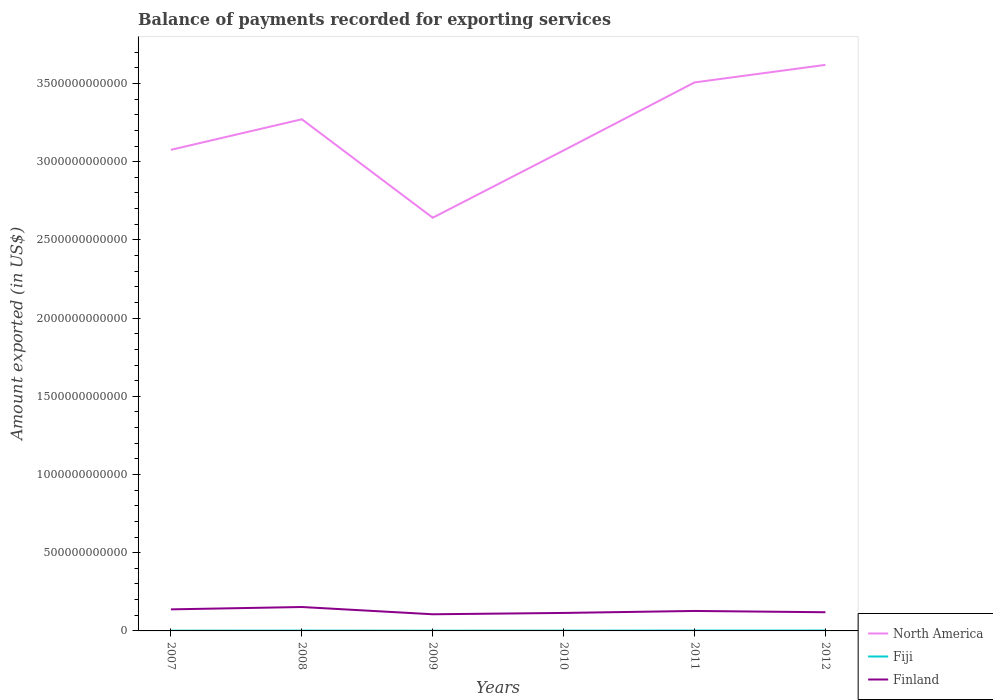How many different coloured lines are there?
Give a very brief answer. 3. Does the line corresponding to North America intersect with the line corresponding to Finland?
Make the answer very short. No. Across all years, what is the maximum amount exported in Finland?
Provide a succinct answer. 1.07e+11. What is the total amount exported in Fiji in the graph?
Provide a short and direct response. -6.14e+08. What is the difference between the highest and the second highest amount exported in Finland?
Your answer should be very brief. 4.63e+1. What is the difference between the highest and the lowest amount exported in Finland?
Your answer should be very brief. 3. How many years are there in the graph?
Provide a short and direct response. 6. What is the difference between two consecutive major ticks on the Y-axis?
Offer a very short reply. 5.00e+11. Does the graph contain any zero values?
Keep it short and to the point. No. Does the graph contain grids?
Give a very brief answer. No. How many legend labels are there?
Your answer should be very brief. 3. How are the legend labels stacked?
Offer a terse response. Vertical. What is the title of the graph?
Your answer should be compact. Balance of payments recorded for exporting services. What is the label or title of the Y-axis?
Provide a succinct answer. Amount exported (in US$). What is the Amount exported (in US$) of North America in 2007?
Your response must be concise. 3.08e+12. What is the Amount exported (in US$) in Fiji in 2007?
Your answer should be very brief. 1.72e+09. What is the Amount exported (in US$) in Finland in 2007?
Your answer should be very brief. 1.38e+11. What is the Amount exported (in US$) of North America in 2008?
Your response must be concise. 3.27e+12. What is the Amount exported (in US$) of Fiji in 2008?
Provide a succinct answer. 2.09e+09. What is the Amount exported (in US$) in Finland in 2008?
Give a very brief answer. 1.53e+11. What is the Amount exported (in US$) of North America in 2009?
Your answer should be very brief. 2.64e+12. What is the Amount exported (in US$) in Fiji in 2009?
Your answer should be very brief. 1.48e+09. What is the Amount exported (in US$) of Finland in 2009?
Offer a terse response. 1.07e+11. What is the Amount exported (in US$) of North America in 2010?
Keep it short and to the point. 3.07e+12. What is the Amount exported (in US$) of Fiji in 2010?
Provide a succinct answer. 1.90e+09. What is the Amount exported (in US$) of Finland in 2010?
Ensure brevity in your answer.  1.15e+11. What is the Amount exported (in US$) of North America in 2011?
Your response must be concise. 3.51e+12. What is the Amount exported (in US$) in Fiji in 2011?
Offer a very short reply. 2.33e+09. What is the Amount exported (in US$) in Finland in 2011?
Provide a succinct answer. 1.28e+11. What is the Amount exported (in US$) in North America in 2012?
Your answer should be very brief. 3.62e+12. What is the Amount exported (in US$) in Fiji in 2012?
Offer a very short reply. 2.51e+09. What is the Amount exported (in US$) of Finland in 2012?
Your response must be concise. 1.20e+11. Across all years, what is the maximum Amount exported (in US$) in North America?
Your response must be concise. 3.62e+12. Across all years, what is the maximum Amount exported (in US$) in Fiji?
Offer a very short reply. 2.51e+09. Across all years, what is the maximum Amount exported (in US$) of Finland?
Your answer should be very brief. 1.53e+11. Across all years, what is the minimum Amount exported (in US$) of North America?
Your answer should be compact. 2.64e+12. Across all years, what is the minimum Amount exported (in US$) of Fiji?
Keep it short and to the point. 1.48e+09. Across all years, what is the minimum Amount exported (in US$) of Finland?
Provide a short and direct response. 1.07e+11. What is the total Amount exported (in US$) of North America in the graph?
Keep it short and to the point. 1.92e+13. What is the total Amount exported (in US$) of Fiji in the graph?
Your answer should be very brief. 1.20e+1. What is the total Amount exported (in US$) of Finland in the graph?
Your answer should be very brief. 7.59e+11. What is the difference between the Amount exported (in US$) in North America in 2007 and that in 2008?
Give a very brief answer. -1.95e+11. What is the difference between the Amount exported (in US$) in Fiji in 2007 and that in 2008?
Make the answer very short. -3.73e+08. What is the difference between the Amount exported (in US$) in Finland in 2007 and that in 2008?
Provide a short and direct response. -1.49e+1. What is the difference between the Amount exported (in US$) of North America in 2007 and that in 2009?
Provide a succinct answer. 4.34e+11. What is the difference between the Amount exported (in US$) of Fiji in 2007 and that in 2009?
Offer a very short reply. 2.34e+08. What is the difference between the Amount exported (in US$) in Finland in 2007 and that in 2009?
Keep it short and to the point. 3.14e+1. What is the difference between the Amount exported (in US$) of North America in 2007 and that in 2010?
Keep it short and to the point. 3.78e+09. What is the difference between the Amount exported (in US$) of Fiji in 2007 and that in 2010?
Keep it short and to the point. -1.82e+08. What is the difference between the Amount exported (in US$) in Finland in 2007 and that in 2010?
Ensure brevity in your answer.  2.29e+1. What is the difference between the Amount exported (in US$) in North America in 2007 and that in 2011?
Keep it short and to the point. -4.31e+11. What is the difference between the Amount exported (in US$) of Fiji in 2007 and that in 2011?
Offer a very short reply. -6.14e+08. What is the difference between the Amount exported (in US$) in Finland in 2007 and that in 2011?
Provide a short and direct response. 1.03e+1. What is the difference between the Amount exported (in US$) in North America in 2007 and that in 2012?
Offer a very short reply. -5.43e+11. What is the difference between the Amount exported (in US$) of Fiji in 2007 and that in 2012?
Keep it short and to the point. -7.94e+08. What is the difference between the Amount exported (in US$) of Finland in 2007 and that in 2012?
Your answer should be compact. 1.84e+1. What is the difference between the Amount exported (in US$) of North America in 2008 and that in 2009?
Give a very brief answer. 6.29e+11. What is the difference between the Amount exported (in US$) of Fiji in 2008 and that in 2009?
Your answer should be very brief. 6.07e+08. What is the difference between the Amount exported (in US$) in Finland in 2008 and that in 2009?
Offer a very short reply. 4.63e+1. What is the difference between the Amount exported (in US$) of North America in 2008 and that in 2010?
Offer a very short reply. 1.99e+11. What is the difference between the Amount exported (in US$) in Fiji in 2008 and that in 2010?
Your response must be concise. 1.92e+08. What is the difference between the Amount exported (in US$) of Finland in 2008 and that in 2010?
Keep it short and to the point. 3.79e+1. What is the difference between the Amount exported (in US$) of North America in 2008 and that in 2011?
Make the answer very short. -2.36e+11. What is the difference between the Amount exported (in US$) in Fiji in 2008 and that in 2011?
Keep it short and to the point. -2.40e+08. What is the difference between the Amount exported (in US$) of Finland in 2008 and that in 2011?
Offer a very short reply. 2.52e+1. What is the difference between the Amount exported (in US$) in North America in 2008 and that in 2012?
Offer a terse response. -3.48e+11. What is the difference between the Amount exported (in US$) in Fiji in 2008 and that in 2012?
Keep it short and to the point. -4.21e+08. What is the difference between the Amount exported (in US$) in Finland in 2008 and that in 2012?
Keep it short and to the point. 3.33e+1. What is the difference between the Amount exported (in US$) in North America in 2009 and that in 2010?
Keep it short and to the point. -4.30e+11. What is the difference between the Amount exported (in US$) of Fiji in 2009 and that in 2010?
Offer a very short reply. -4.15e+08. What is the difference between the Amount exported (in US$) in Finland in 2009 and that in 2010?
Give a very brief answer. -8.47e+09. What is the difference between the Amount exported (in US$) of North America in 2009 and that in 2011?
Give a very brief answer. -8.65e+11. What is the difference between the Amount exported (in US$) of Fiji in 2009 and that in 2011?
Offer a terse response. -8.47e+08. What is the difference between the Amount exported (in US$) in Finland in 2009 and that in 2011?
Your response must be concise. -2.11e+1. What is the difference between the Amount exported (in US$) of North America in 2009 and that in 2012?
Provide a succinct answer. -9.77e+11. What is the difference between the Amount exported (in US$) in Fiji in 2009 and that in 2012?
Keep it short and to the point. -1.03e+09. What is the difference between the Amount exported (in US$) in Finland in 2009 and that in 2012?
Your answer should be very brief. -1.30e+1. What is the difference between the Amount exported (in US$) of North America in 2010 and that in 2011?
Your answer should be compact. -4.35e+11. What is the difference between the Amount exported (in US$) of Fiji in 2010 and that in 2011?
Your response must be concise. -4.32e+08. What is the difference between the Amount exported (in US$) of Finland in 2010 and that in 2011?
Your answer should be compact. -1.27e+1. What is the difference between the Amount exported (in US$) of North America in 2010 and that in 2012?
Your answer should be very brief. -5.47e+11. What is the difference between the Amount exported (in US$) of Fiji in 2010 and that in 2012?
Your response must be concise. -6.12e+08. What is the difference between the Amount exported (in US$) in Finland in 2010 and that in 2012?
Keep it short and to the point. -4.53e+09. What is the difference between the Amount exported (in US$) in North America in 2011 and that in 2012?
Keep it short and to the point. -1.12e+11. What is the difference between the Amount exported (in US$) of Fiji in 2011 and that in 2012?
Keep it short and to the point. -1.80e+08. What is the difference between the Amount exported (in US$) in Finland in 2011 and that in 2012?
Ensure brevity in your answer.  8.12e+09. What is the difference between the Amount exported (in US$) of North America in 2007 and the Amount exported (in US$) of Fiji in 2008?
Keep it short and to the point. 3.07e+12. What is the difference between the Amount exported (in US$) of North America in 2007 and the Amount exported (in US$) of Finland in 2008?
Offer a terse response. 2.92e+12. What is the difference between the Amount exported (in US$) of Fiji in 2007 and the Amount exported (in US$) of Finland in 2008?
Keep it short and to the point. -1.51e+11. What is the difference between the Amount exported (in US$) in North America in 2007 and the Amount exported (in US$) in Fiji in 2009?
Keep it short and to the point. 3.07e+12. What is the difference between the Amount exported (in US$) of North America in 2007 and the Amount exported (in US$) of Finland in 2009?
Give a very brief answer. 2.97e+12. What is the difference between the Amount exported (in US$) in Fiji in 2007 and the Amount exported (in US$) in Finland in 2009?
Keep it short and to the point. -1.05e+11. What is the difference between the Amount exported (in US$) in North America in 2007 and the Amount exported (in US$) in Fiji in 2010?
Provide a succinct answer. 3.07e+12. What is the difference between the Amount exported (in US$) in North America in 2007 and the Amount exported (in US$) in Finland in 2010?
Ensure brevity in your answer.  2.96e+12. What is the difference between the Amount exported (in US$) of Fiji in 2007 and the Amount exported (in US$) of Finland in 2010?
Provide a short and direct response. -1.13e+11. What is the difference between the Amount exported (in US$) of North America in 2007 and the Amount exported (in US$) of Fiji in 2011?
Keep it short and to the point. 3.07e+12. What is the difference between the Amount exported (in US$) of North America in 2007 and the Amount exported (in US$) of Finland in 2011?
Provide a succinct answer. 2.95e+12. What is the difference between the Amount exported (in US$) of Fiji in 2007 and the Amount exported (in US$) of Finland in 2011?
Offer a very short reply. -1.26e+11. What is the difference between the Amount exported (in US$) in North America in 2007 and the Amount exported (in US$) in Fiji in 2012?
Provide a succinct answer. 3.07e+12. What is the difference between the Amount exported (in US$) of North America in 2007 and the Amount exported (in US$) of Finland in 2012?
Make the answer very short. 2.96e+12. What is the difference between the Amount exported (in US$) of Fiji in 2007 and the Amount exported (in US$) of Finland in 2012?
Provide a succinct answer. -1.18e+11. What is the difference between the Amount exported (in US$) of North America in 2008 and the Amount exported (in US$) of Fiji in 2009?
Keep it short and to the point. 3.27e+12. What is the difference between the Amount exported (in US$) in North America in 2008 and the Amount exported (in US$) in Finland in 2009?
Offer a terse response. 3.16e+12. What is the difference between the Amount exported (in US$) of Fiji in 2008 and the Amount exported (in US$) of Finland in 2009?
Keep it short and to the point. -1.04e+11. What is the difference between the Amount exported (in US$) in North America in 2008 and the Amount exported (in US$) in Fiji in 2010?
Give a very brief answer. 3.27e+12. What is the difference between the Amount exported (in US$) in North America in 2008 and the Amount exported (in US$) in Finland in 2010?
Offer a terse response. 3.16e+12. What is the difference between the Amount exported (in US$) of Fiji in 2008 and the Amount exported (in US$) of Finland in 2010?
Your answer should be compact. -1.13e+11. What is the difference between the Amount exported (in US$) in North America in 2008 and the Amount exported (in US$) in Fiji in 2011?
Make the answer very short. 3.27e+12. What is the difference between the Amount exported (in US$) of North America in 2008 and the Amount exported (in US$) of Finland in 2011?
Offer a terse response. 3.14e+12. What is the difference between the Amount exported (in US$) of Fiji in 2008 and the Amount exported (in US$) of Finland in 2011?
Give a very brief answer. -1.26e+11. What is the difference between the Amount exported (in US$) of North America in 2008 and the Amount exported (in US$) of Fiji in 2012?
Make the answer very short. 3.27e+12. What is the difference between the Amount exported (in US$) in North America in 2008 and the Amount exported (in US$) in Finland in 2012?
Give a very brief answer. 3.15e+12. What is the difference between the Amount exported (in US$) in Fiji in 2008 and the Amount exported (in US$) in Finland in 2012?
Provide a short and direct response. -1.17e+11. What is the difference between the Amount exported (in US$) of North America in 2009 and the Amount exported (in US$) of Fiji in 2010?
Your answer should be very brief. 2.64e+12. What is the difference between the Amount exported (in US$) of North America in 2009 and the Amount exported (in US$) of Finland in 2010?
Provide a succinct answer. 2.53e+12. What is the difference between the Amount exported (in US$) of Fiji in 2009 and the Amount exported (in US$) of Finland in 2010?
Offer a terse response. -1.13e+11. What is the difference between the Amount exported (in US$) in North America in 2009 and the Amount exported (in US$) in Fiji in 2011?
Offer a terse response. 2.64e+12. What is the difference between the Amount exported (in US$) of North America in 2009 and the Amount exported (in US$) of Finland in 2011?
Your answer should be very brief. 2.51e+12. What is the difference between the Amount exported (in US$) of Fiji in 2009 and the Amount exported (in US$) of Finland in 2011?
Offer a very short reply. -1.26e+11. What is the difference between the Amount exported (in US$) in North America in 2009 and the Amount exported (in US$) in Fiji in 2012?
Ensure brevity in your answer.  2.64e+12. What is the difference between the Amount exported (in US$) of North America in 2009 and the Amount exported (in US$) of Finland in 2012?
Ensure brevity in your answer.  2.52e+12. What is the difference between the Amount exported (in US$) in Fiji in 2009 and the Amount exported (in US$) in Finland in 2012?
Ensure brevity in your answer.  -1.18e+11. What is the difference between the Amount exported (in US$) of North America in 2010 and the Amount exported (in US$) of Fiji in 2011?
Give a very brief answer. 3.07e+12. What is the difference between the Amount exported (in US$) in North America in 2010 and the Amount exported (in US$) in Finland in 2011?
Your answer should be compact. 2.94e+12. What is the difference between the Amount exported (in US$) of Fiji in 2010 and the Amount exported (in US$) of Finland in 2011?
Give a very brief answer. -1.26e+11. What is the difference between the Amount exported (in US$) in North America in 2010 and the Amount exported (in US$) in Fiji in 2012?
Your answer should be very brief. 3.07e+12. What is the difference between the Amount exported (in US$) of North America in 2010 and the Amount exported (in US$) of Finland in 2012?
Give a very brief answer. 2.95e+12. What is the difference between the Amount exported (in US$) of Fiji in 2010 and the Amount exported (in US$) of Finland in 2012?
Provide a succinct answer. -1.18e+11. What is the difference between the Amount exported (in US$) of North America in 2011 and the Amount exported (in US$) of Fiji in 2012?
Keep it short and to the point. 3.50e+12. What is the difference between the Amount exported (in US$) in North America in 2011 and the Amount exported (in US$) in Finland in 2012?
Make the answer very short. 3.39e+12. What is the difference between the Amount exported (in US$) of Fiji in 2011 and the Amount exported (in US$) of Finland in 2012?
Keep it short and to the point. -1.17e+11. What is the average Amount exported (in US$) of North America per year?
Your answer should be very brief. 3.20e+12. What is the average Amount exported (in US$) of Fiji per year?
Give a very brief answer. 2.00e+09. What is the average Amount exported (in US$) of Finland per year?
Ensure brevity in your answer.  1.27e+11. In the year 2007, what is the difference between the Amount exported (in US$) in North America and Amount exported (in US$) in Fiji?
Keep it short and to the point. 3.07e+12. In the year 2007, what is the difference between the Amount exported (in US$) of North America and Amount exported (in US$) of Finland?
Ensure brevity in your answer.  2.94e+12. In the year 2007, what is the difference between the Amount exported (in US$) in Fiji and Amount exported (in US$) in Finland?
Offer a very short reply. -1.36e+11. In the year 2008, what is the difference between the Amount exported (in US$) of North America and Amount exported (in US$) of Fiji?
Your answer should be compact. 3.27e+12. In the year 2008, what is the difference between the Amount exported (in US$) of North America and Amount exported (in US$) of Finland?
Provide a succinct answer. 3.12e+12. In the year 2008, what is the difference between the Amount exported (in US$) of Fiji and Amount exported (in US$) of Finland?
Provide a succinct answer. -1.51e+11. In the year 2009, what is the difference between the Amount exported (in US$) in North America and Amount exported (in US$) in Fiji?
Your answer should be very brief. 2.64e+12. In the year 2009, what is the difference between the Amount exported (in US$) in North America and Amount exported (in US$) in Finland?
Keep it short and to the point. 2.54e+12. In the year 2009, what is the difference between the Amount exported (in US$) in Fiji and Amount exported (in US$) in Finland?
Your answer should be compact. -1.05e+11. In the year 2010, what is the difference between the Amount exported (in US$) in North America and Amount exported (in US$) in Fiji?
Your response must be concise. 3.07e+12. In the year 2010, what is the difference between the Amount exported (in US$) in North America and Amount exported (in US$) in Finland?
Make the answer very short. 2.96e+12. In the year 2010, what is the difference between the Amount exported (in US$) in Fiji and Amount exported (in US$) in Finland?
Offer a terse response. -1.13e+11. In the year 2011, what is the difference between the Amount exported (in US$) of North America and Amount exported (in US$) of Fiji?
Offer a very short reply. 3.50e+12. In the year 2011, what is the difference between the Amount exported (in US$) of North America and Amount exported (in US$) of Finland?
Make the answer very short. 3.38e+12. In the year 2011, what is the difference between the Amount exported (in US$) of Fiji and Amount exported (in US$) of Finland?
Offer a very short reply. -1.25e+11. In the year 2012, what is the difference between the Amount exported (in US$) in North America and Amount exported (in US$) in Fiji?
Make the answer very short. 3.62e+12. In the year 2012, what is the difference between the Amount exported (in US$) in North America and Amount exported (in US$) in Finland?
Offer a very short reply. 3.50e+12. In the year 2012, what is the difference between the Amount exported (in US$) of Fiji and Amount exported (in US$) of Finland?
Your response must be concise. -1.17e+11. What is the ratio of the Amount exported (in US$) in North America in 2007 to that in 2008?
Provide a short and direct response. 0.94. What is the ratio of the Amount exported (in US$) in Fiji in 2007 to that in 2008?
Give a very brief answer. 0.82. What is the ratio of the Amount exported (in US$) of Finland in 2007 to that in 2008?
Your response must be concise. 0.9. What is the ratio of the Amount exported (in US$) of North America in 2007 to that in 2009?
Make the answer very short. 1.16. What is the ratio of the Amount exported (in US$) in Fiji in 2007 to that in 2009?
Make the answer very short. 1.16. What is the ratio of the Amount exported (in US$) in Finland in 2007 to that in 2009?
Give a very brief answer. 1.29. What is the ratio of the Amount exported (in US$) of North America in 2007 to that in 2010?
Offer a terse response. 1. What is the ratio of the Amount exported (in US$) of Fiji in 2007 to that in 2010?
Provide a short and direct response. 0.9. What is the ratio of the Amount exported (in US$) in Finland in 2007 to that in 2010?
Your answer should be very brief. 1.2. What is the ratio of the Amount exported (in US$) of North America in 2007 to that in 2011?
Keep it short and to the point. 0.88. What is the ratio of the Amount exported (in US$) of Fiji in 2007 to that in 2011?
Your answer should be compact. 0.74. What is the ratio of the Amount exported (in US$) in Finland in 2007 to that in 2011?
Offer a very short reply. 1.08. What is the ratio of the Amount exported (in US$) in North America in 2007 to that in 2012?
Your answer should be very brief. 0.85. What is the ratio of the Amount exported (in US$) of Fiji in 2007 to that in 2012?
Give a very brief answer. 0.68. What is the ratio of the Amount exported (in US$) in Finland in 2007 to that in 2012?
Provide a succinct answer. 1.15. What is the ratio of the Amount exported (in US$) in North America in 2008 to that in 2009?
Provide a short and direct response. 1.24. What is the ratio of the Amount exported (in US$) of Fiji in 2008 to that in 2009?
Ensure brevity in your answer.  1.41. What is the ratio of the Amount exported (in US$) in Finland in 2008 to that in 2009?
Provide a short and direct response. 1.44. What is the ratio of the Amount exported (in US$) of North America in 2008 to that in 2010?
Your response must be concise. 1.06. What is the ratio of the Amount exported (in US$) of Fiji in 2008 to that in 2010?
Your response must be concise. 1.1. What is the ratio of the Amount exported (in US$) of Finland in 2008 to that in 2010?
Your answer should be compact. 1.33. What is the ratio of the Amount exported (in US$) in North America in 2008 to that in 2011?
Offer a very short reply. 0.93. What is the ratio of the Amount exported (in US$) in Fiji in 2008 to that in 2011?
Offer a very short reply. 0.9. What is the ratio of the Amount exported (in US$) in Finland in 2008 to that in 2011?
Ensure brevity in your answer.  1.2. What is the ratio of the Amount exported (in US$) of North America in 2008 to that in 2012?
Your answer should be compact. 0.9. What is the ratio of the Amount exported (in US$) in Fiji in 2008 to that in 2012?
Your response must be concise. 0.83. What is the ratio of the Amount exported (in US$) in Finland in 2008 to that in 2012?
Give a very brief answer. 1.28. What is the ratio of the Amount exported (in US$) in North America in 2009 to that in 2010?
Provide a succinct answer. 0.86. What is the ratio of the Amount exported (in US$) of Fiji in 2009 to that in 2010?
Offer a terse response. 0.78. What is the ratio of the Amount exported (in US$) in Finland in 2009 to that in 2010?
Provide a short and direct response. 0.93. What is the ratio of the Amount exported (in US$) of North America in 2009 to that in 2011?
Provide a succinct answer. 0.75. What is the ratio of the Amount exported (in US$) of Fiji in 2009 to that in 2011?
Offer a very short reply. 0.64. What is the ratio of the Amount exported (in US$) in Finland in 2009 to that in 2011?
Your answer should be very brief. 0.83. What is the ratio of the Amount exported (in US$) in North America in 2009 to that in 2012?
Make the answer very short. 0.73. What is the ratio of the Amount exported (in US$) in Fiji in 2009 to that in 2012?
Ensure brevity in your answer.  0.59. What is the ratio of the Amount exported (in US$) of Finland in 2009 to that in 2012?
Make the answer very short. 0.89. What is the ratio of the Amount exported (in US$) of North America in 2010 to that in 2011?
Provide a succinct answer. 0.88. What is the ratio of the Amount exported (in US$) in Fiji in 2010 to that in 2011?
Your answer should be compact. 0.81. What is the ratio of the Amount exported (in US$) in Finland in 2010 to that in 2011?
Your answer should be compact. 0.9. What is the ratio of the Amount exported (in US$) of North America in 2010 to that in 2012?
Give a very brief answer. 0.85. What is the ratio of the Amount exported (in US$) of Fiji in 2010 to that in 2012?
Give a very brief answer. 0.76. What is the ratio of the Amount exported (in US$) in Finland in 2010 to that in 2012?
Offer a terse response. 0.96. What is the ratio of the Amount exported (in US$) in Fiji in 2011 to that in 2012?
Your answer should be compact. 0.93. What is the ratio of the Amount exported (in US$) in Finland in 2011 to that in 2012?
Make the answer very short. 1.07. What is the difference between the highest and the second highest Amount exported (in US$) in North America?
Give a very brief answer. 1.12e+11. What is the difference between the highest and the second highest Amount exported (in US$) of Fiji?
Provide a succinct answer. 1.80e+08. What is the difference between the highest and the second highest Amount exported (in US$) in Finland?
Give a very brief answer. 1.49e+1. What is the difference between the highest and the lowest Amount exported (in US$) of North America?
Make the answer very short. 9.77e+11. What is the difference between the highest and the lowest Amount exported (in US$) of Fiji?
Keep it short and to the point. 1.03e+09. What is the difference between the highest and the lowest Amount exported (in US$) in Finland?
Your answer should be very brief. 4.63e+1. 